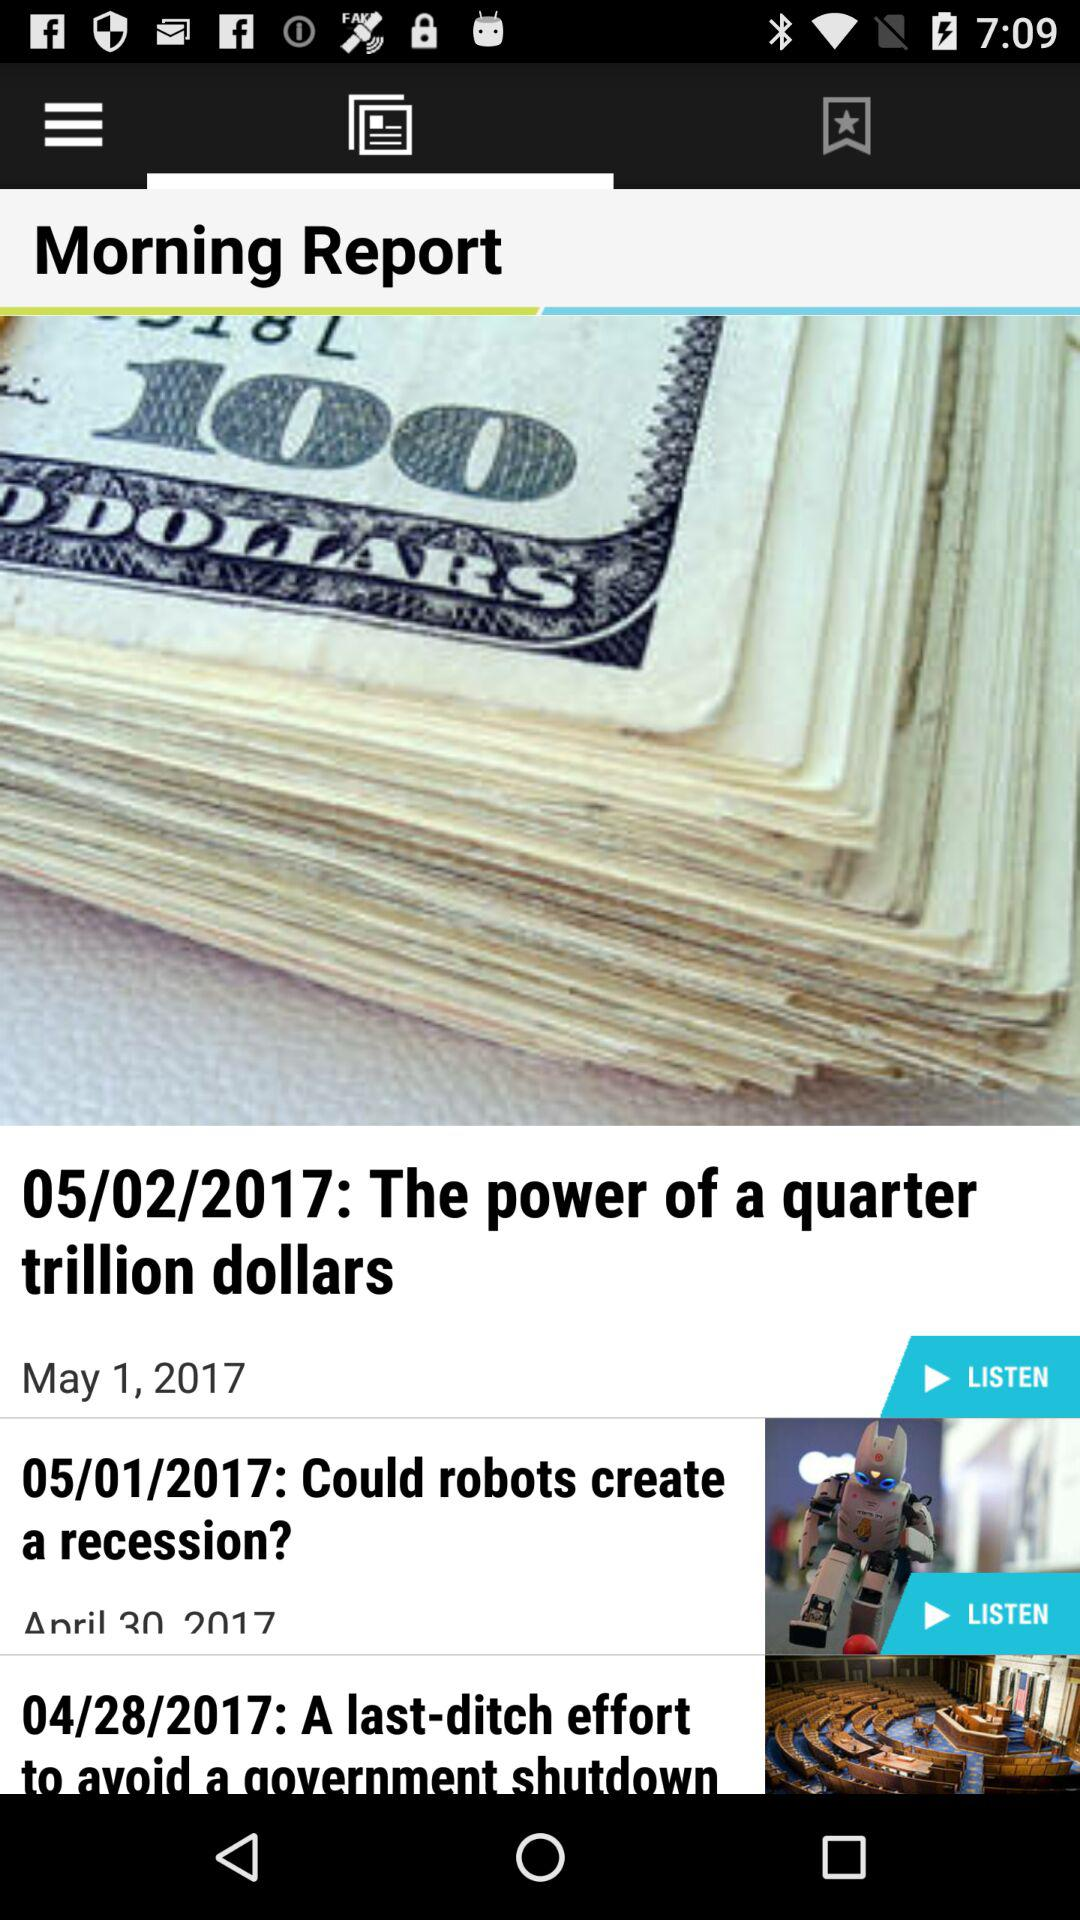How many stories does this article have?
Answer the question using a single word or phrase. 3 